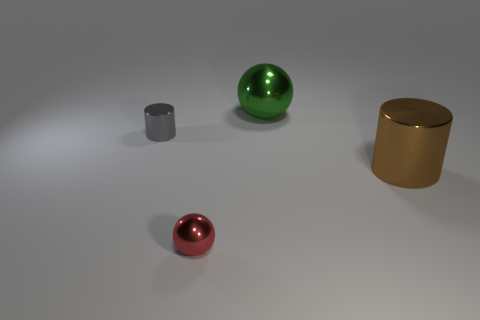Are there any big brown cylinders that are in front of the cylinder in front of the small shiny thing that is behind the brown thing?
Provide a succinct answer. No. Are there fewer tiny metal balls left of the red shiny thing than metal things in front of the gray shiny object?
Your response must be concise. Yes. The large ball that is made of the same material as the large brown object is what color?
Your answer should be very brief. Green. The big object that is in front of the big metal thing that is behind the small gray object is what color?
Give a very brief answer. Brown. Is there a tiny metal thing of the same color as the tiny metallic ball?
Your response must be concise. No. The green metal thing that is the same size as the brown thing is what shape?
Give a very brief answer. Sphere. How many spheres are on the right side of the metallic ball that is on the left side of the green ball?
Provide a succinct answer. 1. Does the big metal ball have the same color as the tiny metal ball?
Offer a terse response. No. What number of other things are there of the same material as the gray cylinder
Make the answer very short. 3. What shape is the small thing to the right of the tiny metal thing that is left of the tiny red object?
Your answer should be very brief. Sphere. 